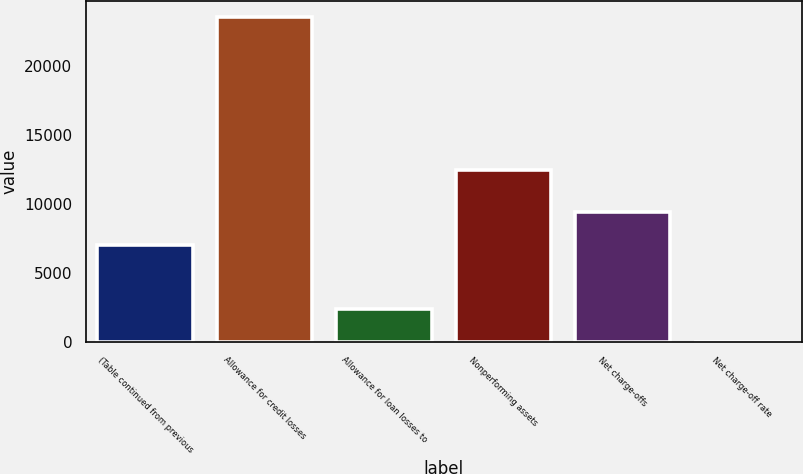<chart> <loc_0><loc_0><loc_500><loc_500><bar_chart><fcel>(Table continued from previous<fcel>Allowance for credit losses<fcel>Allowance for loan losses to<fcel>Nonperforming assets<fcel>Net charge-offs<fcel>Net charge-off rate<nl><fcel>7073.88<fcel>23576<fcel>2358.98<fcel>12481<fcel>9431.33<fcel>1.53<nl></chart> 